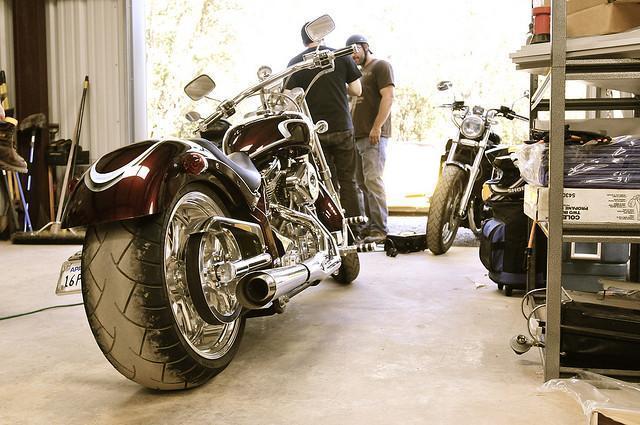How many people are in front of the motorcycle?
Give a very brief answer. 2. How many people are visible?
Give a very brief answer. 2. How many motorcycles are visible?
Give a very brief answer. 2. How many toothbrushes are on the counter?
Give a very brief answer. 0. 